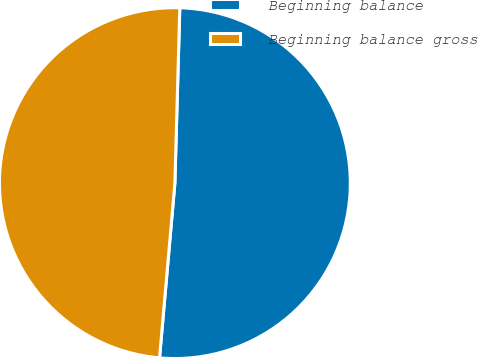Convert chart. <chart><loc_0><loc_0><loc_500><loc_500><pie_chart><fcel>Beginning balance<fcel>Beginning balance gross<nl><fcel>50.95%<fcel>49.05%<nl></chart> 